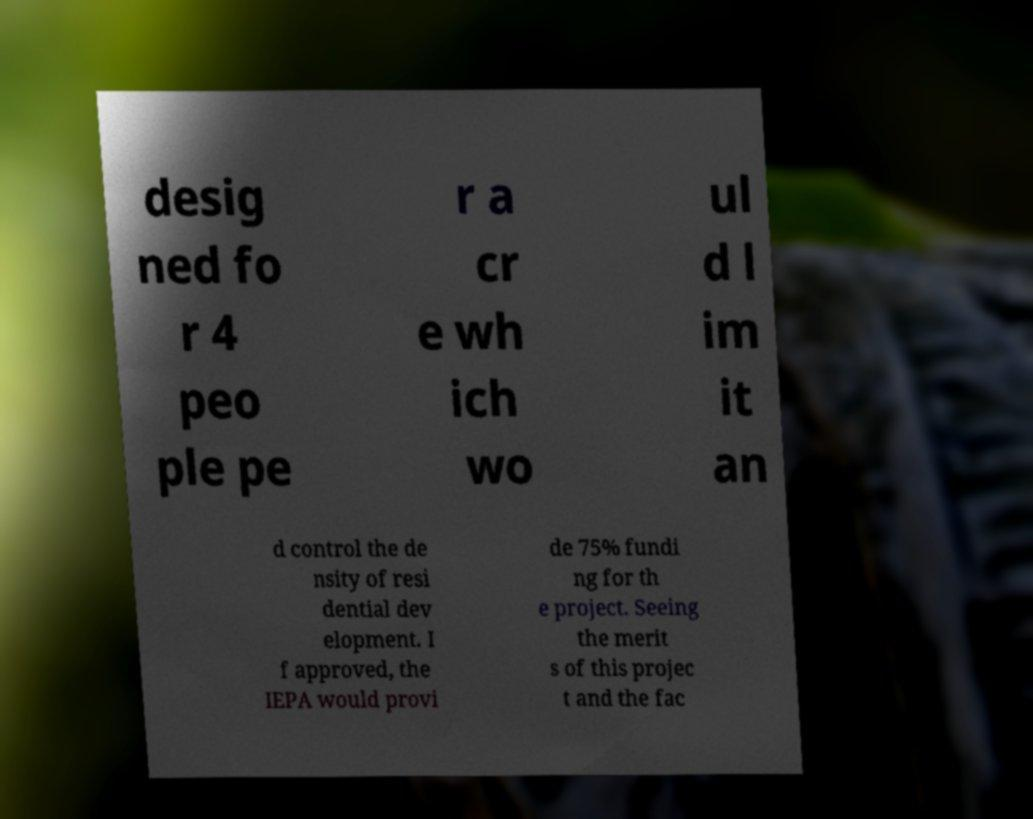For documentation purposes, I need the text within this image transcribed. Could you provide that? desig ned fo r 4 peo ple pe r a cr e wh ich wo ul d l im it an d control the de nsity of resi dential dev elopment. I f approved, the IEPA would provi de 75% fundi ng for th e project. Seeing the merit s of this projec t and the fac 